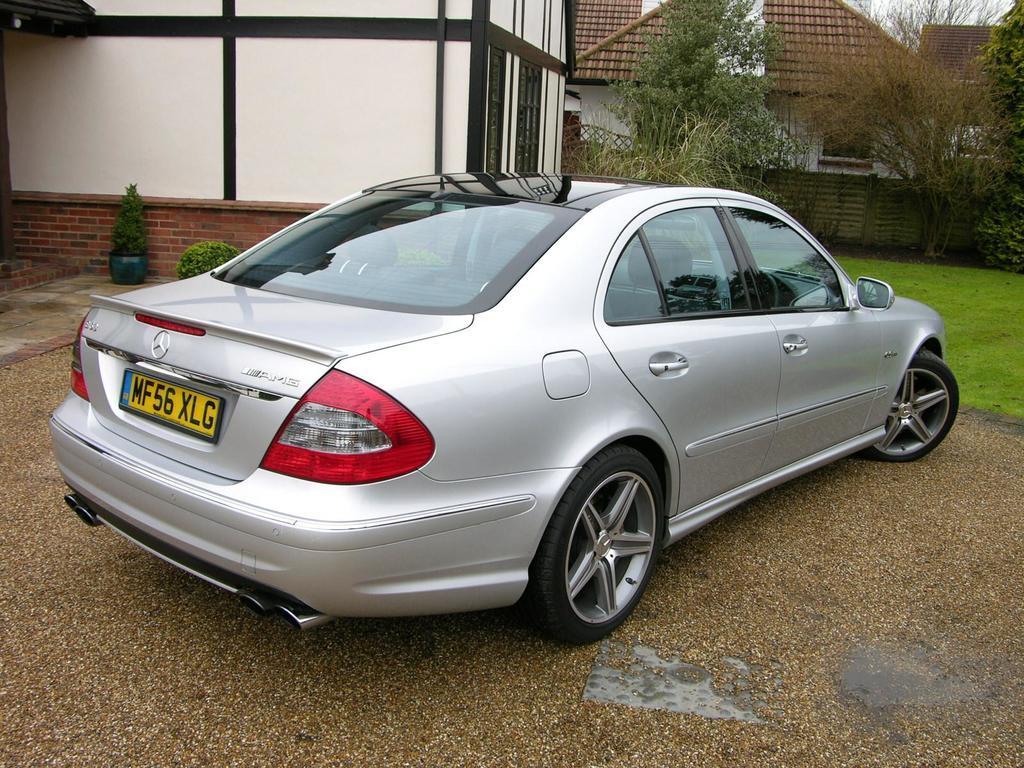In one or two sentences, can you explain what this image depicts? n this image we can see houses, plants, grass, sand, car and we can also see wooden object. 